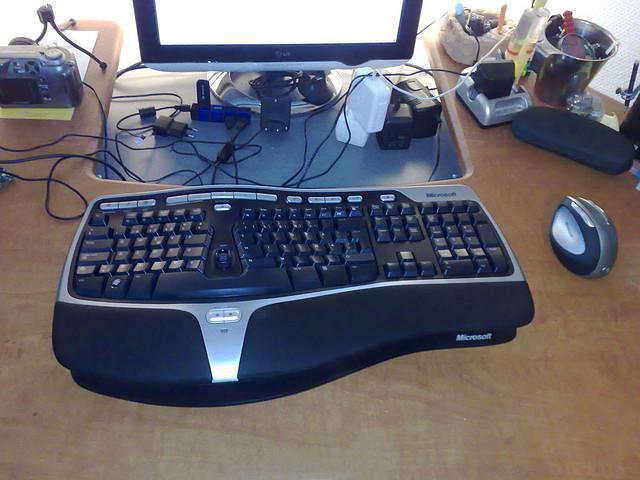What are the corded objects used for?
Pick the right solution, then justify: 'Answer: answer
Rationale: rationale.'
Options: Dividing objects, powering devices, organizing objects, testing voltage. Answer: powering devices.
Rationale: The cords put power to the devices. 